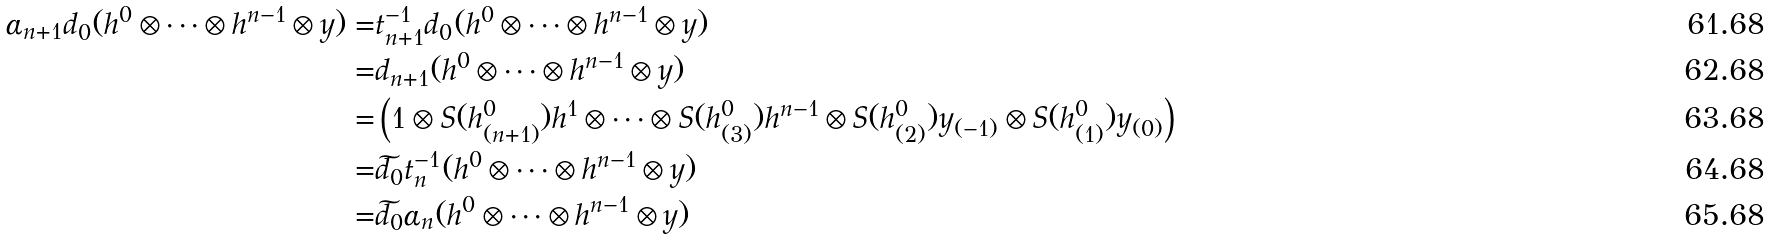<formula> <loc_0><loc_0><loc_500><loc_500>\alpha _ { n + 1 } d _ { 0 } ( h ^ { 0 } \otimes \cdots \otimes h ^ { n - 1 } \otimes y ) = & t _ { n + 1 } ^ { - 1 } d _ { 0 } ( h ^ { 0 } \otimes \cdots \otimes h ^ { n - 1 } \otimes y ) \\ = & d _ { n + 1 } ( h ^ { 0 } \otimes \cdots \otimes h ^ { n - 1 } \otimes y ) \\ = & \left ( 1 \otimes S ( h ^ { 0 } _ { ( n + 1 ) } ) h ^ { 1 } \otimes \cdots \otimes S ( h ^ { 0 } _ { ( 3 ) } ) h ^ { n - 1 } \otimes S ( h ^ { 0 } _ { ( 2 ) } ) y _ { ( - 1 ) } \otimes S ( h ^ { 0 } _ { ( 1 ) } ) y _ { ( 0 ) } \right ) \\ = & \widetilde { d _ { 0 } } t _ { n } ^ { - 1 } ( h ^ { 0 } \otimes \cdots \otimes h ^ { n - 1 } \otimes y ) \\ = & \widetilde { d _ { 0 } } \alpha _ { n } ( h ^ { 0 } \otimes \cdots \otimes h ^ { n - 1 } \otimes y )</formula> 